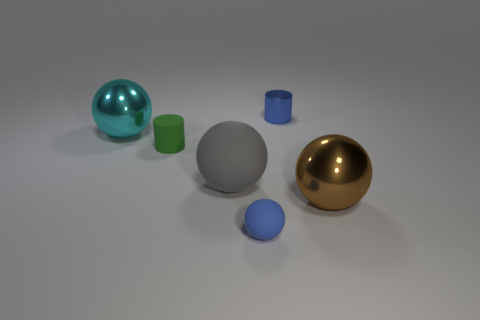What color is the other small object that is the same shape as the small blue shiny object?
Make the answer very short. Green. There is a tiny blue metallic thing; does it have the same shape as the metal thing on the left side of the tiny blue cylinder?
Ensure brevity in your answer.  No. How many things are large things on the right side of the blue rubber object or balls that are right of the green matte cylinder?
Provide a succinct answer. 3. Is the number of small blue matte spheres that are behind the blue metallic object less than the number of large gray rubber objects?
Your response must be concise. Yes. Is the gray object made of the same material as the tiny cylinder that is in front of the cyan ball?
Ensure brevity in your answer.  Yes. What material is the gray sphere?
Provide a succinct answer. Rubber. What is the large object that is to the right of the tiny blue thing that is in front of the gray sphere that is in front of the small green rubber cylinder made of?
Your response must be concise. Metal. There is a small metallic object; is its color the same as the big metal sphere right of the tiny blue rubber thing?
Offer a terse response. No. Is there any other thing that is the same shape as the gray matte object?
Provide a short and direct response. Yes. The big metal object on the left side of the big shiny sphere that is right of the blue rubber thing is what color?
Your answer should be very brief. Cyan. 